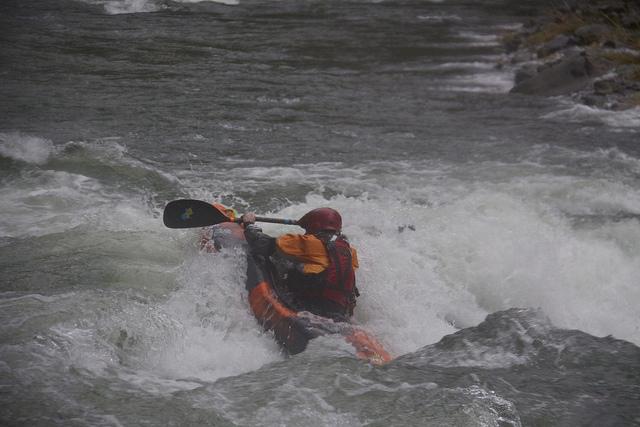What is the man riding on?
Keep it brief. Kayak. What sport is the man doing?
Write a very short answer. Kayaking. What is this man doing?
Concise answer only. Kayaking. What is the woman doing?
Concise answer only. Kayaking. Why is this man dressed in a wetsuit?
Concise answer only. Kayaking. What is this woman doing?
Write a very short answer. Kayaking. What object is the camera resting on?
Give a very brief answer. Rock. Is the man a good surfer?
Be succinct. No. What is he doing on top of the water?
Write a very short answer. Kayaking. What is this young man doing?
Write a very short answer. Kayaking. Is this the ocean?
Short answer required. No. Is the person sitting?
Answer briefly. Yes. What is the person holding?
Keep it brief. Paddle. Is the guy in danger?
Concise answer only. Yes. What is the guy holding onto?
Write a very short answer. Paddle. What is man riding?
Be succinct. Kayak. Where is the man?
Give a very brief answer. In kayak. What is the person riding?
Answer briefly. Kayak. What sport is he playing?
Answer briefly. Kayaking. What are the men in the photo doing?
Write a very short answer. Kayaking. What is the surfing on?
Give a very brief answer. Rapids. What is the person doing?
Quick response, please. Kayaking. Where was this photo taken?
Write a very short answer. River. What is the man doing?
Concise answer only. Kayaking. What is this person doing?
Answer briefly. Kayaking. Is the man wearing a shirt?
Be succinct. Yes. What are these people doing?
Answer briefly. Kayaking. What's the man doing?
Keep it brief. Kayaking. What color is the paddle?
Quick response, please. Black. What is the women wearing?
Short answer required. Life jacket. What is the person riding in?
Short answer required. Kayak. What is the man riding?
Be succinct. Kayak. What is this man on?
Give a very brief answer. Kayak. Was this picture taken at the beach?
Write a very short answer. No. Is the person wearing a helmet?
Write a very short answer. Yes. What is man doing?
Give a very brief answer. Kayaking. What are the rafters looking at?
Quick response, please. Water. What is the person doing in the water?
Concise answer only. Kayaking. How many people are sitting in kayaks?
Concise answer only. 1. 